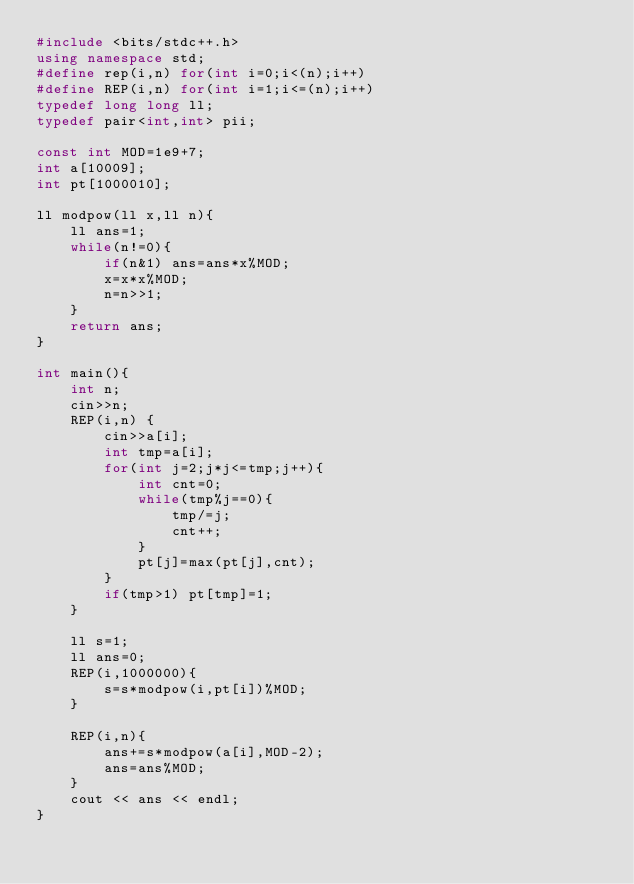Convert code to text. <code><loc_0><loc_0><loc_500><loc_500><_C++_>#include <bits/stdc++.h>
using namespace std;
#define rep(i,n) for(int i=0;i<(n);i++)
#define REP(i,n) for(int i=1;i<=(n);i++)
typedef long long ll;
typedef pair<int,int> pii;

const int MOD=1e9+7;
int a[10009];
int pt[1000010];

ll modpow(ll x,ll n){
    ll ans=1;
    while(n!=0){
        if(n&1) ans=ans*x%MOD;
        x=x*x%MOD;
        n=n>>1; 
    }
    return ans;
}

int main(){
    int n;
    cin>>n;
    REP(i,n) {
        cin>>a[i];
        int tmp=a[i];
        for(int j=2;j*j<=tmp;j++){
            int cnt=0;
            while(tmp%j==0){
                tmp/=j;
                cnt++;
            }
            pt[j]=max(pt[j],cnt);
        }
        if(tmp>1) pt[tmp]=1;
    }
    
    ll s=1;
    ll ans=0;
    REP(i,1000000){
        s=s*modpow(i,pt[i])%MOD;
    }  
    
    REP(i,n){
        ans+=s*modpow(a[i],MOD-2);
        ans=ans%MOD;
    }
    cout << ans << endl;
}</code> 